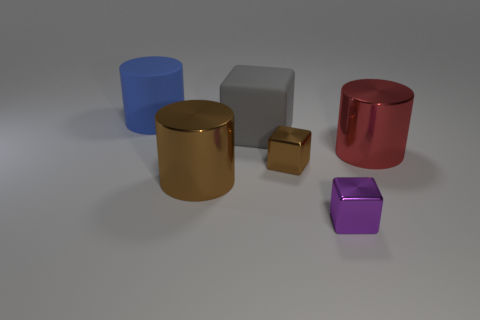Subtract all big gray matte cubes. How many cubes are left? 2 Add 2 tiny cyan blocks. How many objects exist? 8 Subtract all big red metallic cylinders. Subtract all small brown things. How many objects are left? 4 Add 5 large rubber cubes. How many large rubber cubes are left? 6 Add 3 tiny shiny blocks. How many tiny shiny blocks exist? 5 Subtract 0 gray cylinders. How many objects are left? 6 